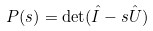<formula> <loc_0><loc_0><loc_500><loc_500>P ( s ) = \det ( \hat { I } - s \hat { U } )</formula> 